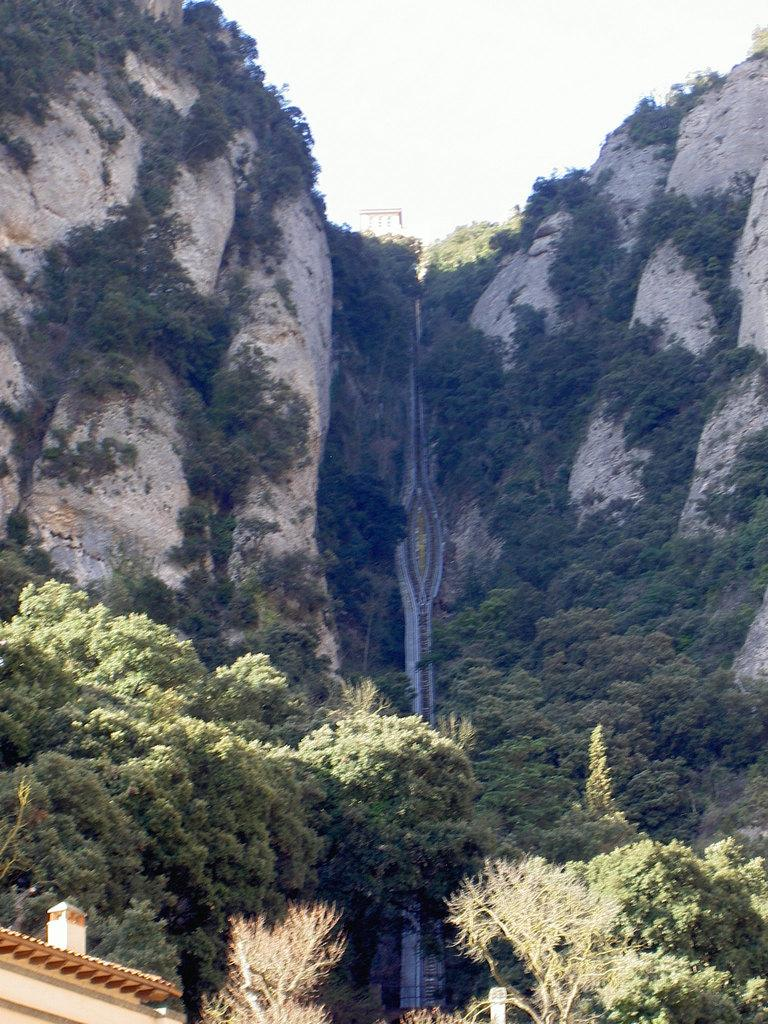How many hills can be seen in the image? There are two hills in the image. What can be found between the hills? There are plenty of trees between the hills. What type of growth can be seen on the trees in the image? There is no information about the growth on the trees in the image. Can you describe how the trees are distributed between the hills? The distribution of the trees between the hills cannot be determined from the image. 